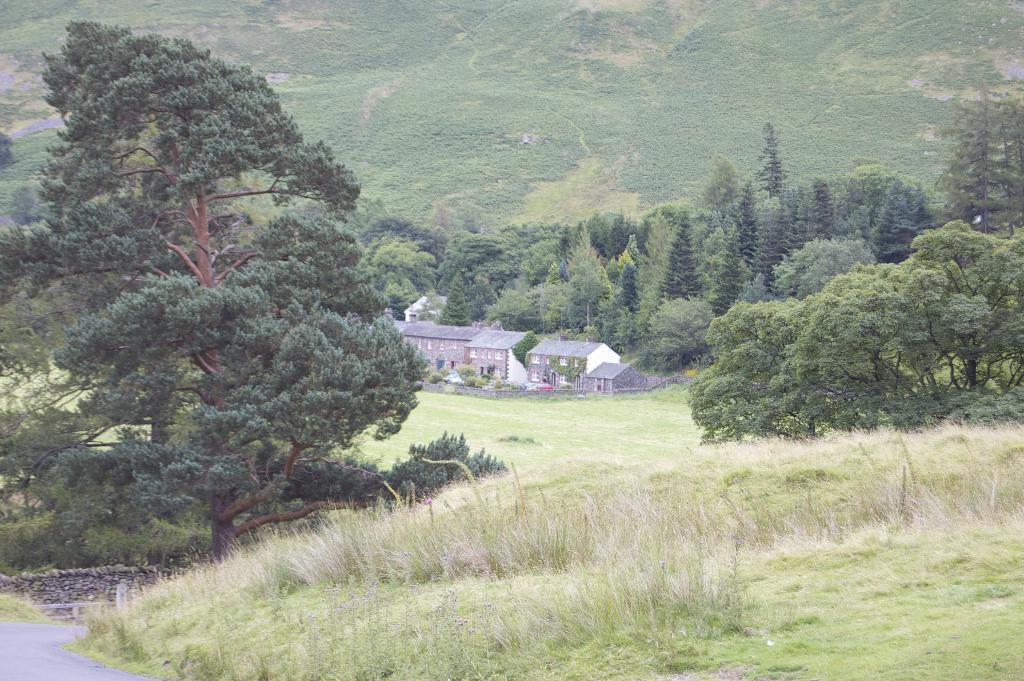What type of vegetation is present in the image? There is grass in the image. What other natural elements can be seen in the image? There are trees in the image. What type of man-made structures are visible in the image? There are buildings in the image. What geographical feature can be seen in the background of the image? In the background of the image, there is a hill. What type of payment is required to climb the hill in the image? There is no mention of payment or any requirement to climb the hill in the image. The hill is simply a geographical feature in the background. 